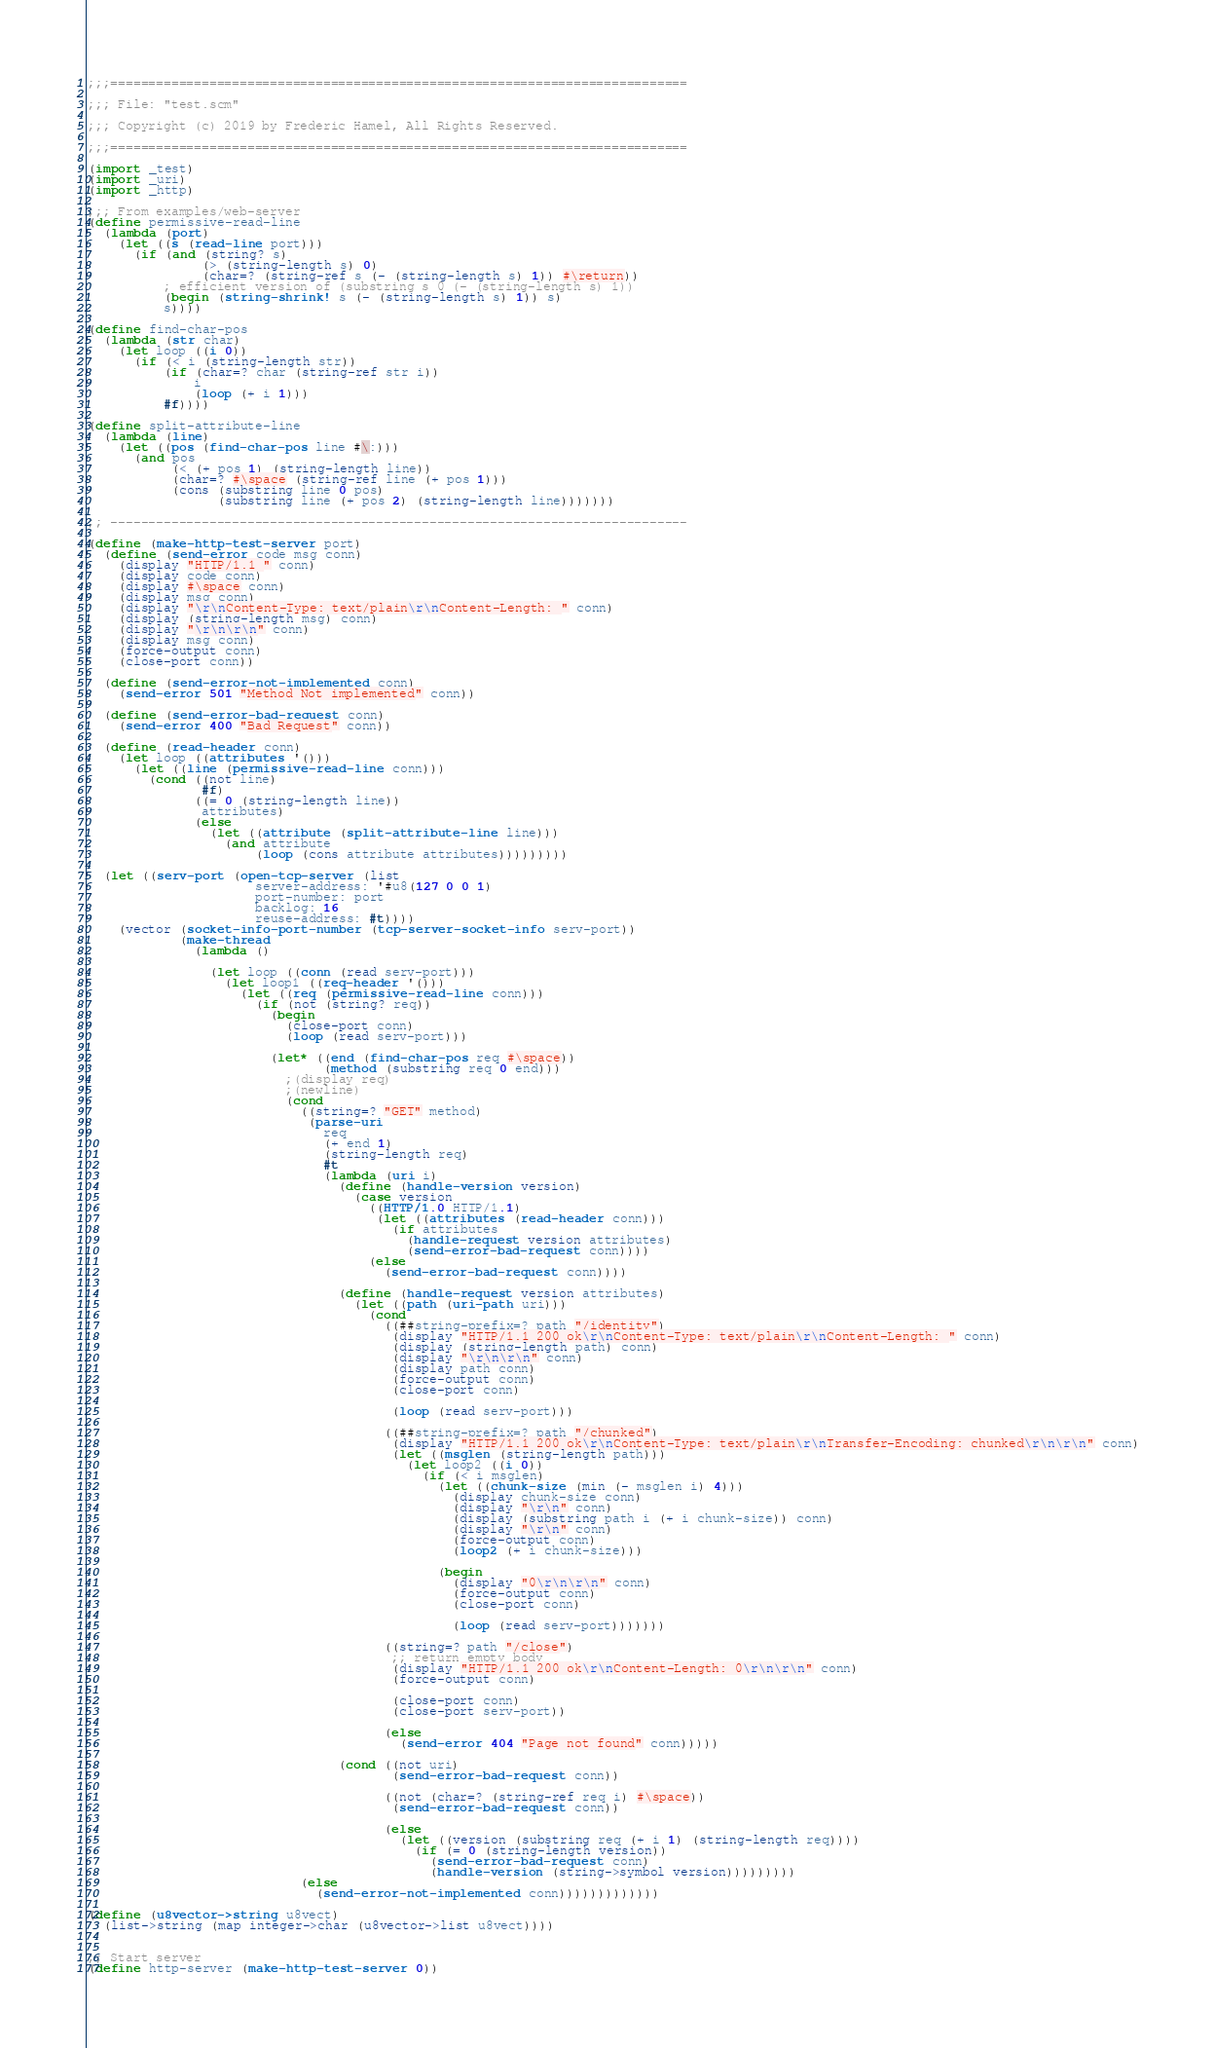<code> <loc_0><loc_0><loc_500><loc_500><_Scheme_>;;;============================================================================

;;; File: "test.scm"

;;; Copyright (c) 2019 by Frédéric Hamel, All Rights Reserved.

;;;============================================================================

(import _test)
(import _uri)
(import _http)

;;; From examples/web-server
(define permissive-read-line
  (lambda (port)
    (let ((s (read-line port)))
      (if (and (string? s)
               (> (string-length s) 0)
               (char=? (string-ref s (- (string-length s) 1)) #\return))
          ; efficient version of (substring s 0 (- (string-length s) 1))
          (begin (string-shrink! s (- (string-length s) 1)) s)
          s))))

(define find-char-pos
  (lambda (str char)
    (let loop ((i 0))
      (if (< i (string-length str))
          (if (char=? char (string-ref str i))
              i
              (loop (+ i 1)))
          #f))))

(define split-attribute-line
  (lambda (line)
    (let ((pos (find-char-pos line #\:)))
      (and pos
           (< (+ pos 1) (string-length line))
           (char=? #\space (string-ref line (+ pos 1)))
           (cons (substring line 0 pos)
                 (substring line (+ pos 2) (string-length line)))))))

;; ----------------------------------------------------------------------------

(define (make-http-test-server port)
  (define (send-error code msg conn)
    (display "HTTP/1.1 " conn)
    (display code conn)
    (display #\space conn)
    (display msg conn)
    (display "\r\nContent-Type: text/plain\r\nContent-Length: " conn)
    (display (string-length msg) conn)
    (display "\r\n\r\n" conn)
    (display msg conn)
    (force-output conn)
    (close-port conn))

  (define (send-error-not-implemented conn)
    (send-error 501 "Method Not implemented" conn))

  (define (send-error-bad-request conn)
    (send-error 400 "Bad Request" conn))

  (define (read-header conn)
    (let loop ((attributes '()))
      (let ((line (permissive-read-line conn)))
        (cond ((not line)
               #f)
              ((= 0 (string-length line))
               attributes)
              (else
                (let ((attribute (split-attribute-line line)))
                  (and attribute
                      (loop (cons attribute attributes)))))))))

  (let ((serv-port (open-tcp-server (list
                      server-address: '#u8(127 0 0 1)
                      port-number: port
                      backlog: 16
                      reuse-address: #t))))
    (vector (socket-info-port-number (tcp-server-socket-info serv-port))
            (make-thread
              (lambda ()

                (let loop ((conn (read serv-port)))
                  (let loop1 ((req-header '()))
                    (let ((req (permissive-read-line conn)))
                      (if (not (string? req))
                        (begin
                          (close-port conn)
                          (loop (read serv-port)))

                        (let* ((end (find-char-pos req #\space))
                               (method (substring req 0 end)))
                          ;(display req)
                          ;(newline)
                          (cond
                            ((string=? "GET" method)
                             (parse-uri
                               req
                               (+ end 1)
                               (string-length req)
                               #t
                               (lambda (uri i)
                                 (define (handle-version version)
                                   (case version
                                     ((HTTP/1.0 HTTP/1.1)
                                      (let ((attributes (read-header conn)))
                                        (if attributes
                                          (handle-request version attributes)
                                          (send-error-bad-request conn))))
                                     (else
                                       (send-error-bad-request conn))))

                                 (define (handle-request version attributes)
                                   (let ((path (uri-path uri)))
                                     (cond
                                       ((##string-prefix=? path "/identity")
                                        (display "HTTP/1.1 200 ok\r\nContent-Type: text/plain\r\nContent-Length: " conn)
                                        (display (string-length path) conn)
                                        (display "\r\n\r\n" conn)
                                        (display path conn)
                                        (force-output conn)
                                        (close-port conn)

                                        (loop (read serv-port)))

                                       ((##string-prefix=? path "/chunked")
                                        (display "HTTP/1.1 200 ok\r\nContent-Type: text/plain\r\nTransfer-Encoding: chunked\r\n\r\n" conn)
                                        (let ((msglen (string-length path)))
                                          (let loop2 ((i 0))
                                            (if (< i msglen)
                                              (let ((chunk-size (min (- msglen i) 4)))
                                                (display chunk-size conn)
                                                (display "\r\n" conn)
                                                (display (substring path i (+ i chunk-size)) conn)
                                                (display "\r\n" conn)
                                                (force-output conn)
                                                (loop2 (+ i chunk-size)))

                                              (begin
                                                (display "0\r\n\r\n" conn)
                                                (force-output conn)
                                                (close-port conn)

                                                (loop (read serv-port)))))))

                                       ((string=? path "/close")
                                        ;; return empty body
                                        (display "HTTP/1.1 200 ok\r\nContent-Length: 0\r\n\r\n" conn)
                                        (force-output conn)

                                        (close-port conn)
                                        (close-port serv-port))

                                       (else
                                         (send-error 404 "Page not found" conn)))))

                                 (cond ((not uri)
                                        (send-error-bad-request conn))

                                       ((not (char=? (string-ref req i) #\space))
                                        (send-error-bad-request conn))

                                       (else
                                         (let ((version (substring req (+ i 1) (string-length req))))
                                           (if (= 0 (string-length version))
                                             (send-error-bad-request conn)
                                             (handle-version (string->symbol version)))))))))
                            (else
                              (send-error-not-implemented conn)))))))))))))

(define (u8vector->string u8vect)
  (list->string (map integer->char (u8vector->list u8vect))))


;; Start server
(define http-server (make-http-test-server 0))</code> 